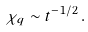Convert formula to latex. <formula><loc_0><loc_0><loc_500><loc_500>\chi _ { q } \sim t ^ { - 1 / 2 } \, .</formula> 